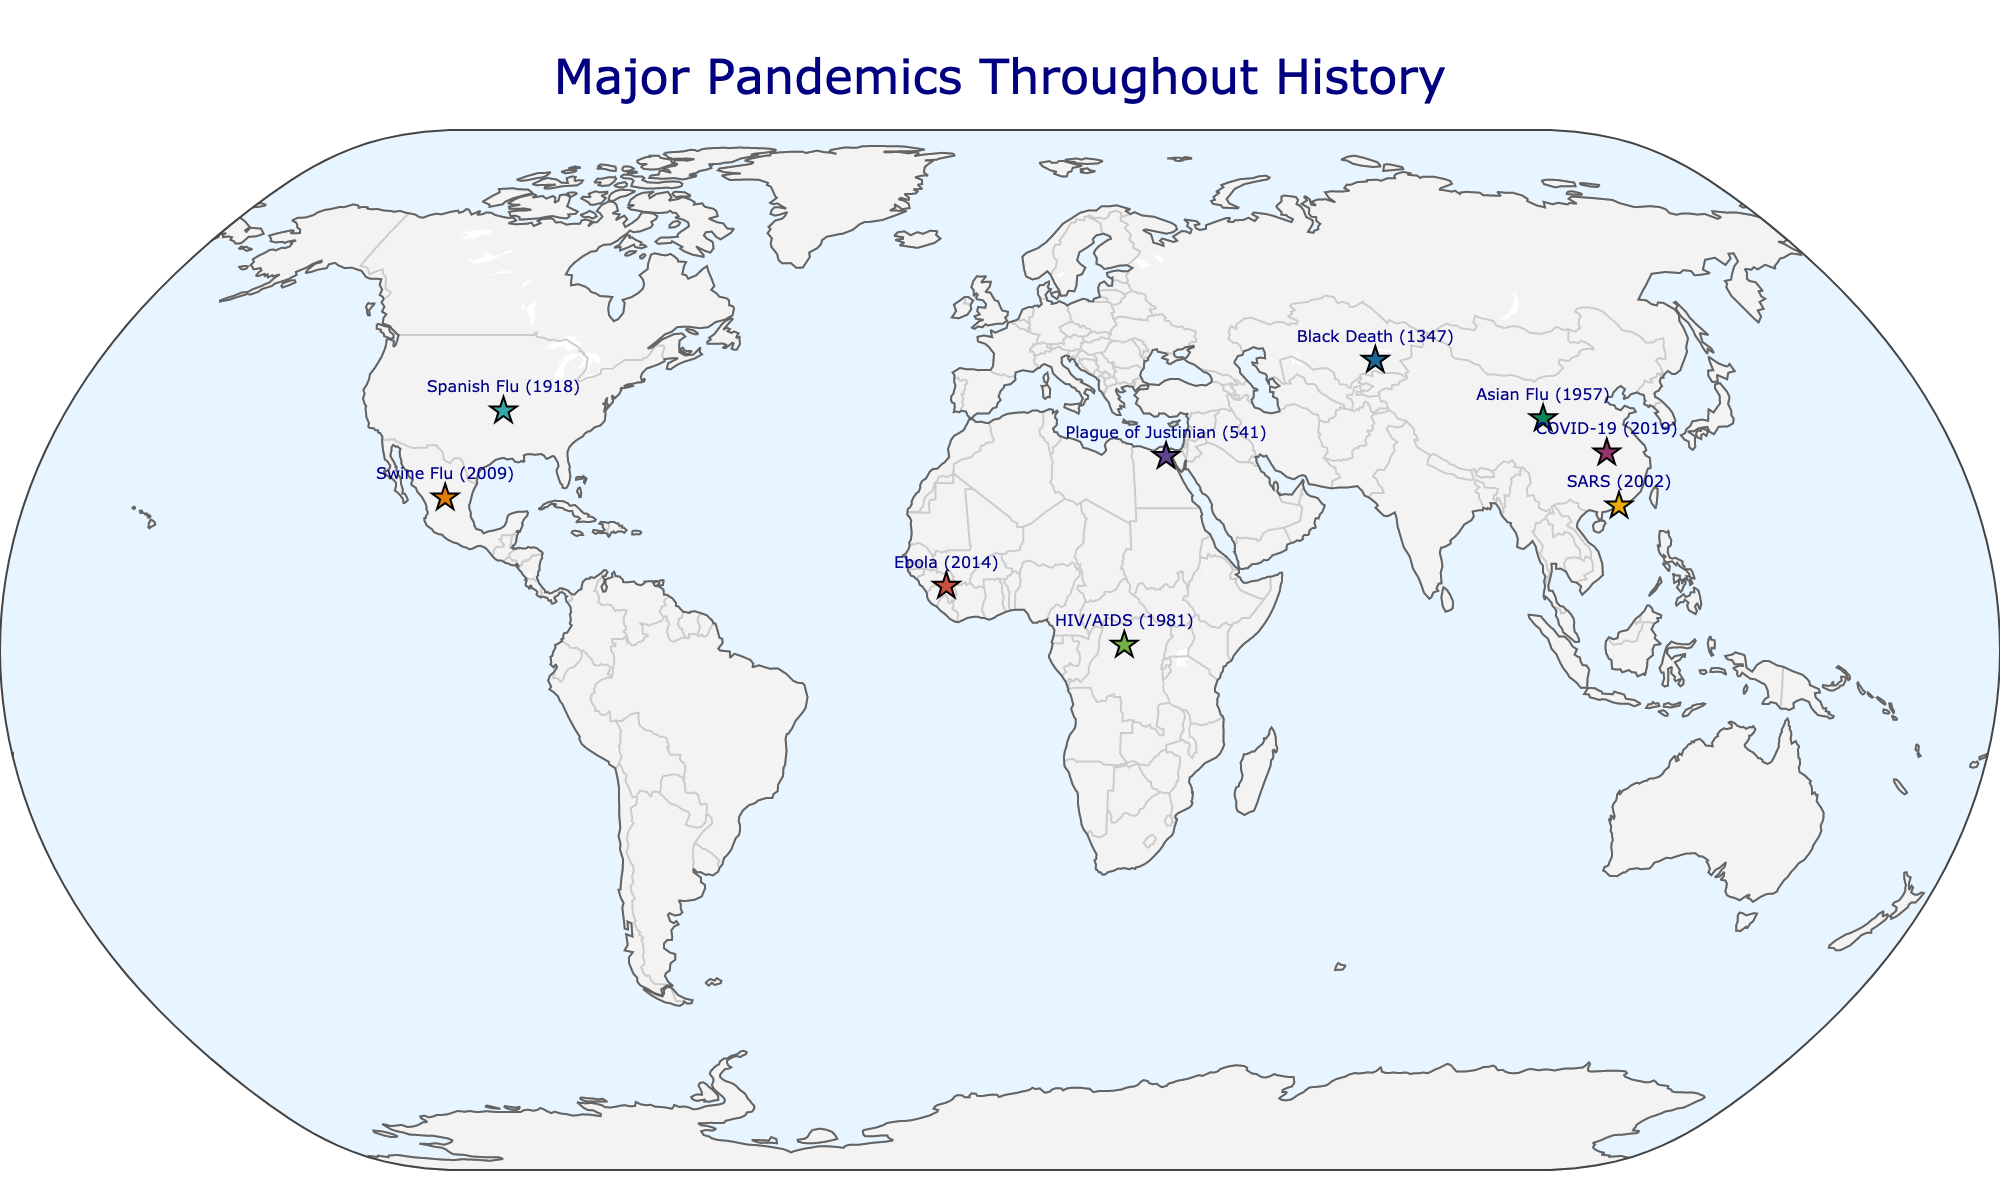How many pandemics originated in China? There are three pandemics with their origin marked in China on the map: Asian Flu, SARS, and COVID-19.
Answer: Three What is the title of the figure? The title of the figure, located at the top center, is "Major Pandemics Throughout History".
Answer: Major Pandemics Throughout History Which pandemic had its origin point closest to the equator? The pandemic originating closest to the equator is HIV/AIDS, with its origin in Central Africa (0.7832, 22.3795).
Answer: HIV/AIDS How many pandemics had a worldwide impact? The map shows that Spanish Flu, HIV/AIDS, and COVID-19 are marked as having worldwide impact.
Answer: Three Which pandemic originated in the United States? The map shows the Spanish Flu originated from the United States (37.0902, -95.7129).
Answer: Spanish Flu Compare the geographic impact of the Black Death and the Swine Flu. Which affected more regions? The Black Death affected Europe, the Middle East, and North Africa, totaling three regions. The Swine Flu affected North America, South America, Europe, and Asia, totaling four regions. Therefore, the Swine Flu affected more regions.
Answer: Swine Flu What year did the SARS pandemic originate? The text next to the marker for SARS on the map indicates it originated in the year 2002.
Answer: 2002 If you average the latitude coordinates of pandemics originating in China, what is the result? The latitude coordinates for the pandemics originating in China are 35.8617 (Asian Flu), 22.3964 (SARS), and 30.5928 (COVID-19). Average = (35.8617 + 22.3964 + 30.5928) / 3 = 29.6170.
Answer: 29.6170 Which two pandemics have their origins closest to each other in terms of latitude and longitude? To find the closest origins, compare the geographic coordinates. The closest pair is SARS (22.3964, 114.1095) and COVID-19 (30.5928, 114.3055) both originating from China with very close longitude values.
Answer: SARS and COVID-19 In which regions did the Plague of Justinian spread? The map shows that the Plague of Justinian affected the Byzantine Empire, Sasanian Empire, and Western Europe.
Answer: Byzantine Empire, Sasanian Empire, Western Europe 